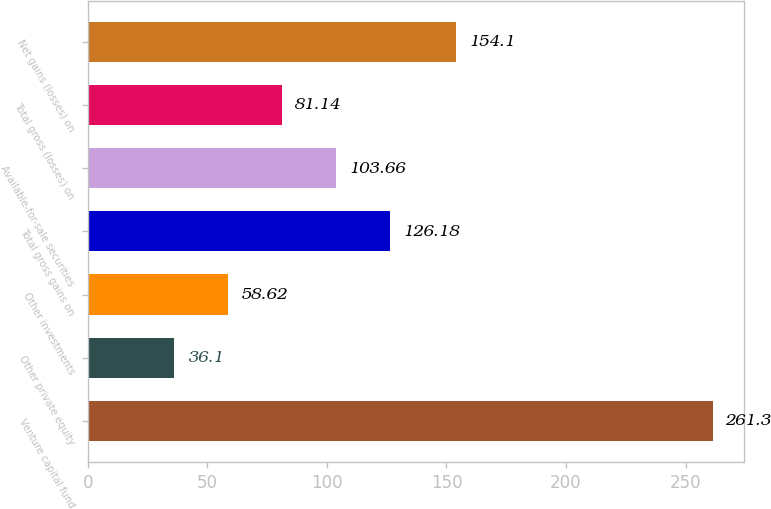<chart> <loc_0><loc_0><loc_500><loc_500><bar_chart><fcel>Venture capital fund<fcel>Other private equity<fcel>Other investments<fcel>Total gross gains on<fcel>Available-for-sale securities<fcel>Total gross (losses) on<fcel>Net gains (losses) on<nl><fcel>261.3<fcel>36.1<fcel>58.62<fcel>126.18<fcel>103.66<fcel>81.14<fcel>154.1<nl></chart> 